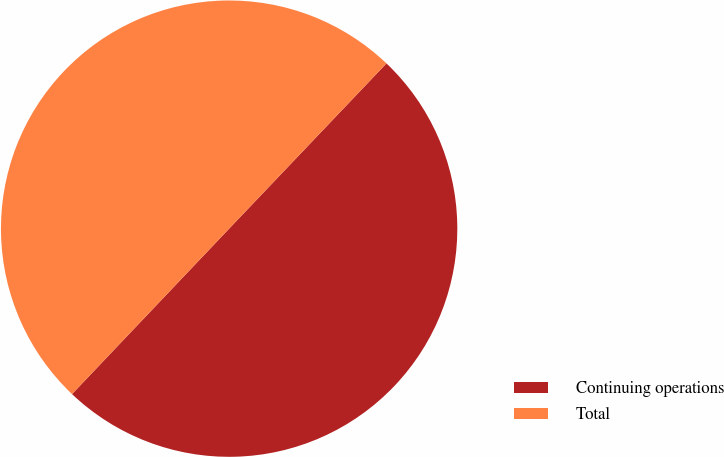Convert chart to OTSL. <chart><loc_0><loc_0><loc_500><loc_500><pie_chart><fcel>Continuing operations<fcel>Total<nl><fcel>49.98%<fcel>50.02%<nl></chart> 